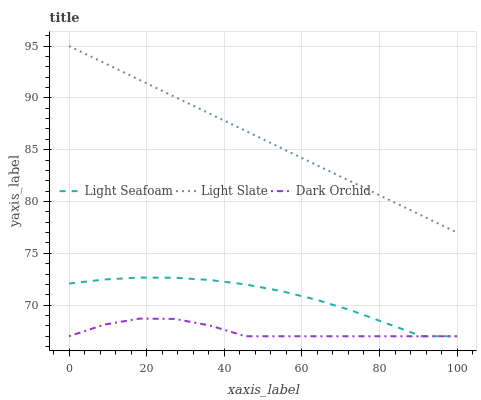Does Dark Orchid have the minimum area under the curve?
Answer yes or no. Yes. Does Light Slate have the maximum area under the curve?
Answer yes or no. Yes. Does Light Seafoam have the minimum area under the curve?
Answer yes or no. No. Does Light Seafoam have the maximum area under the curve?
Answer yes or no. No. Is Light Slate the smoothest?
Answer yes or no. Yes. Is Dark Orchid the roughest?
Answer yes or no. Yes. Is Light Seafoam the smoothest?
Answer yes or no. No. Is Light Seafoam the roughest?
Answer yes or no. No. Does Light Seafoam have the lowest value?
Answer yes or no. Yes. Does Light Slate have the highest value?
Answer yes or no. Yes. Does Light Seafoam have the highest value?
Answer yes or no. No. Is Light Seafoam less than Light Slate?
Answer yes or no. Yes. Is Light Slate greater than Dark Orchid?
Answer yes or no. Yes. Does Dark Orchid intersect Light Seafoam?
Answer yes or no. Yes. Is Dark Orchid less than Light Seafoam?
Answer yes or no. No. Is Dark Orchid greater than Light Seafoam?
Answer yes or no. No. Does Light Seafoam intersect Light Slate?
Answer yes or no. No. 